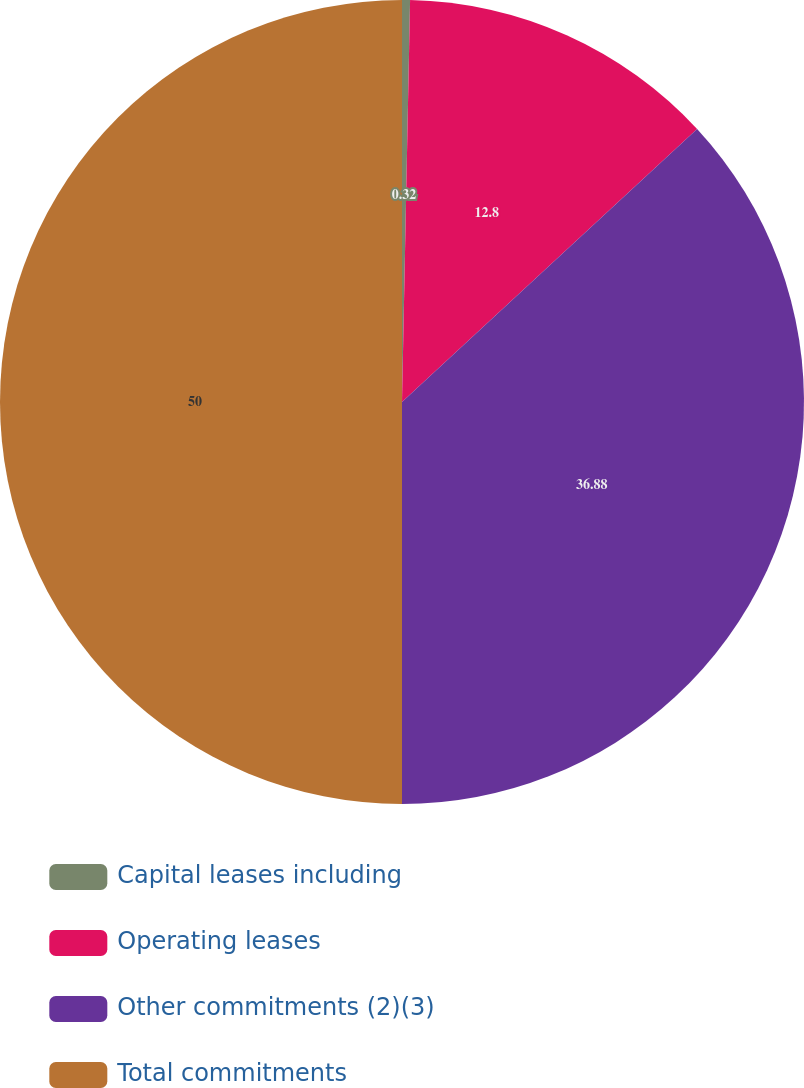Convert chart to OTSL. <chart><loc_0><loc_0><loc_500><loc_500><pie_chart><fcel>Capital leases including<fcel>Operating leases<fcel>Other commitments (2)(3)<fcel>Total commitments<nl><fcel>0.32%<fcel>12.8%<fcel>36.88%<fcel>50.0%<nl></chart> 